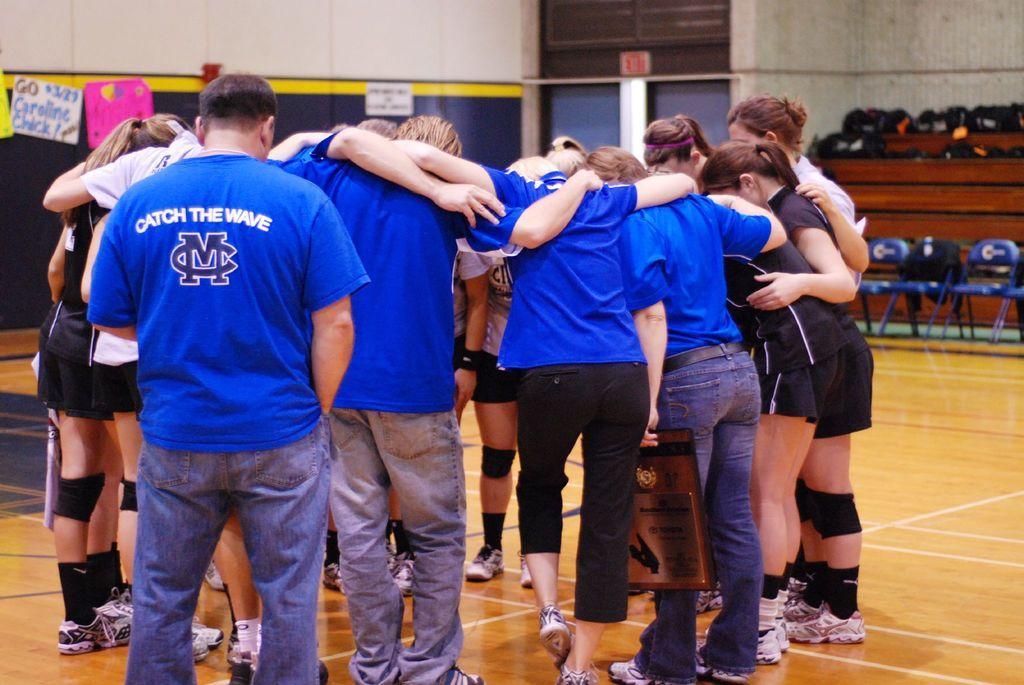Can you describe this image briefly? Here few people are standing,they wore blue color t-shirts. On the right side a girl is standing, she wore a black color t-shirt. They all are standing together. 